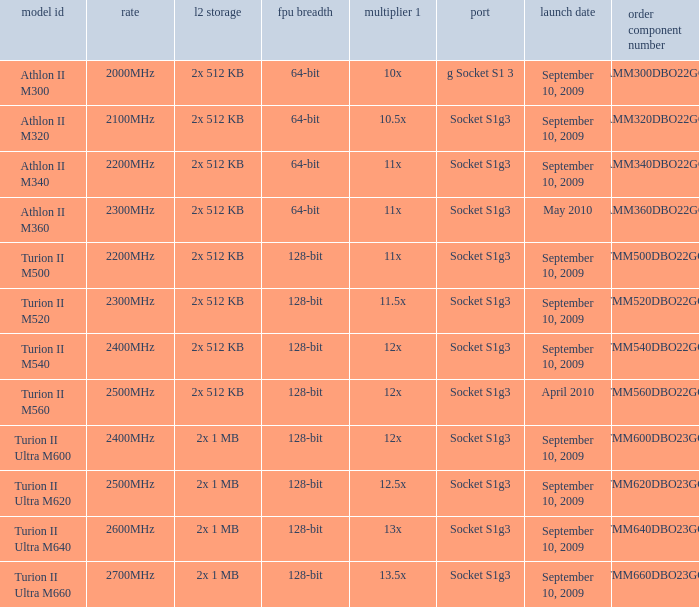What is the L2 cache with a release date on September 10, 2009, a 128-bit FPU width, and a 12x multi 1? 2x 512 KB, 2x 1 MB. 